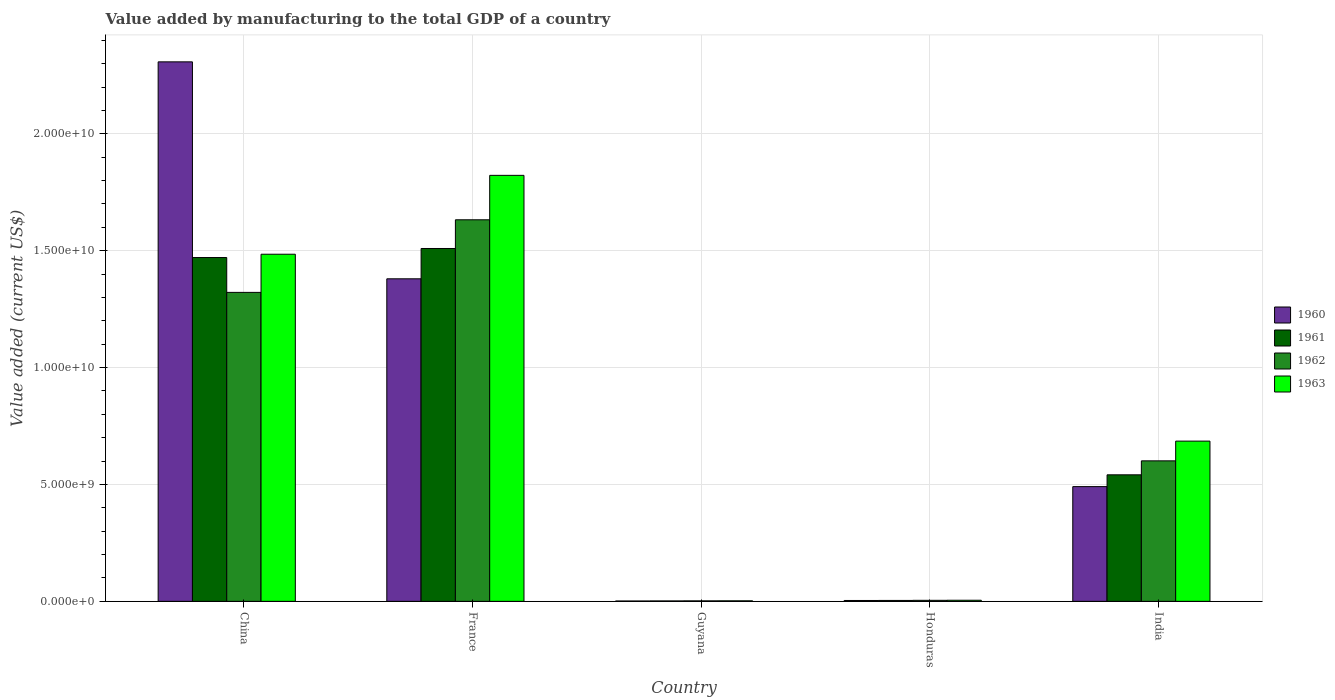Are the number of bars per tick equal to the number of legend labels?
Ensure brevity in your answer.  Yes. Are the number of bars on each tick of the X-axis equal?
Ensure brevity in your answer.  Yes. How many bars are there on the 1st tick from the left?
Offer a very short reply. 4. What is the label of the 3rd group of bars from the left?
Your answer should be very brief. Guyana. What is the value added by manufacturing to the total GDP in 1961 in Guyana?
Provide a succinct answer. 1.84e+07. Across all countries, what is the maximum value added by manufacturing to the total GDP in 1962?
Your response must be concise. 1.63e+1. Across all countries, what is the minimum value added by manufacturing to the total GDP in 1961?
Ensure brevity in your answer.  1.84e+07. In which country was the value added by manufacturing to the total GDP in 1960 minimum?
Make the answer very short. Guyana. What is the total value added by manufacturing to the total GDP in 1962 in the graph?
Ensure brevity in your answer.  3.56e+1. What is the difference between the value added by manufacturing to the total GDP in 1960 in China and that in France?
Your response must be concise. 9.28e+09. What is the difference between the value added by manufacturing to the total GDP in 1961 in Honduras and the value added by manufacturing to the total GDP in 1962 in France?
Keep it short and to the point. -1.63e+1. What is the average value added by manufacturing to the total GDP in 1960 per country?
Make the answer very short. 8.37e+09. What is the difference between the value added by manufacturing to the total GDP of/in 1963 and value added by manufacturing to the total GDP of/in 1960 in Guyana?
Provide a succinct answer. 7.29e+06. What is the ratio of the value added by manufacturing to the total GDP in 1963 in Honduras to that in India?
Provide a short and direct response. 0.01. What is the difference between the highest and the second highest value added by manufacturing to the total GDP in 1963?
Offer a very short reply. 8.00e+09. What is the difference between the highest and the lowest value added by manufacturing to the total GDP in 1960?
Offer a terse response. 2.31e+1. Is it the case that in every country, the sum of the value added by manufacturing to the total GDP in 1961 and value added by manufacturing to the total GDP in 1960 is greater than the sum of value added by manufacturing to the total GDP in 1962 and value added by manufacturing to the total GDP in 1963?
Ensure brevity in your answer.  No. What does the 2nd bar from the right in France represents?
Provide a short and direct response. 1962. Is it the case that in every country, the sum of the value added by manufacturing to the total GDP in 1961 and value added by manufacturing to the total GDP in 1960 is greater than the value added by manufacturing to the total GDP in 1962?
Your response must be concise. Yes. How many bars are there?
Ensure brevity in your answer.  20. Are all the bars in the graph horizontal?
Give a very brief answer. No. What is the difference between two consecutive major ticks on the Y-axis?
Offer a terse response. 5.00e+09. Are the values on the major ticks of Y-axis written in scientific E-notation?
Your answer should be compact. Yes. Does the graph contain grids?
Provide a short and direct response. Yes. Where does the legend appear in the graph?
Keep it short and to the point. Center right. How many legend labels are there?
Offer a very short reply. 4. What is the title of the graph?
Ensure brevity in your answer.  Value added by manufacturing to the total GDP of a country. What is the label or title of the Y-axis?
Your answer should be very brief. Value added (current US$). What is the Value added (current US$) of 1960 in China?
Ensure brevity in your answer.  2.31e+1. What is the Value added (current US$) in 1961 in China?
Your answer should be very brief. 1.47e+1. What is the Value added (current US$) in 1962 in China?
Make the answer very short. 1.32e+1. What is the Value added (current US$) in 1963 in China?
Give a very brief answer. 1.49e+1. What is the Value added (current US$) in 1960 in France?
Give a very brief answer. 1.38e+1. What is the Value added (current US$) of 1961 in France?
Make the answer very short. 1.51e+1. What is the Value added (current US$) in 1962 in France?
Your answer should be very brief. 1.63e+1. What is the Value added (current US$) of 1963 in France?
Your answer should be very brief. 1.82e+1. What is the Value added (current US$) in 1960 in Guyana?
Offer a terse response. 1.59e+07. What is the Value added (current US$) of 1961 in Guyana?
Your answer should be very brief. 1.84e+07. What is the Value added (current US$) in 1962 in Guyana?
Offer a very short reply. 2.08e+07. What is the Value added (current US$) in 1963 in Guyana?
Offer a terse response. 2.32e+07. What is the Value added (current US$) of 1960 in Honduras?
Offer a very short reply. 3.80e+07. What is the Value added (current US$) of 1961 in Honduras?
Make the answer very short. 4.00e+07. What is the Value added (current US$) of 1962 in Honduras?
Provide a succinct answer. 4.41e+07. What is the Value added (current US$) of 1963 in Honduras?
Your answer should be very brief. 4.76e+07. What is the Value added (current US$) of 1960 in India?
Make the answer very short. 4.91e+09. What is the Value added (current US$) of 1961 in India?
Make the answer very short. 5.41e+09. What is the Value added (current US$) in 1962 in India?
Provide a succinct answer. 6.01e+09. What is the Value added (current US$) of 1963 in India?
Make the answer very short. 6.85e+09. Across all countries, what is the maximum Value added (current US$) of 1960?
Your answer should be compact. 2.31e+1. Across all countries, what is the maximum Value added (current US$) in 1961?
Your response must be concise. 1.51e+1. Across all countries, what is the maximum Value added (current US$) of 1962?
Offer a terse response. 1.63e+1. Across all countries, what is the maximum Value added (current US$) in 1963?
Provide a short and direct response. 1.82e+1. Across all countries, what is the minimum Value added (current US$) of 1960?
Give a very brief answer. 1.59e+07. Across all countries, what is the minimum Value added (current US$) of 1961?
Ensure brevity in your answer.  1.84e+07. Across all countries, what is the minimum Value added (current US$) in 1962?
Offer a very short reply. 2.08e+07. Across all countries, what is the minimum Value added (current US$) in 1963?
Your response must be concise. 2.32e+07. What is the total Value added (current US$) of 1960 in the graph?
Give a very brief answer. 4.18e+1. What is the total Value added (current US$) of 1961 in the graph?
Your answer should be compact. 3.53e+1. What is the total Value added (current US$) in 1962 in the graph?
Keep it short and to the point. 3.56e+1. What is the total Value added (current US$) of 1963 in the graph?
Provide a succinct answer. 4.00e+1. What is the difference between the Value added (current US$) in 1960 in China and that in France?
Provide a short and direct response. 9.28e+09. What is the difference between the Value added (current US$) in 1961 in China and that in France?
Ensure brevity in your answer.  -3.87e+08. What is the difference between the Value added (current US$) in 1962 in China and that in France?
Offer a very short reply. -3.11e+09. What is the difference between the Value added (current US$) of 1963 in China and that in France?
Provide a short and direct response. -3.37e+09. What is the difference between the Value added (current US$) of 1960 in China and that in Guyana?
Give a very brief answer. 2.31e+1. What is the difference between the Value added (current US$) in 1961 in China and that in Guyana?
Provide a succinct answer. 1.47e+1. What is the difference between the Value added (current US$) in 1962 in China and that in Guyana?
Give a very brief answer. 1.32e+1. What is the difference between the Value added (current US$) of 1963 in China and that in Guyana?
Give a very brief answer. 1.48e+1. What is the difference between the Value added (current US$) of 1960 in China and that in Honduras?
Your answer should be very brief. 2.30e+1. What is the difference between the Value added (current US$) of 1961 in China and that in Honduras?
Provide a succinct answer. 1.47e+1. What is the difference between the Value added (current US$) in 1962 in China and that in Honduras?
Provide a succinct answer. 1.32e+1. What is the difference between the Value added (current US$) in 1963 in China and that in Honduras?
Offer a terse response. 1.48e+1. What is the difference between the Value added (current US$) of 1960 in China and that in India?
Your answer should be very brief. 1.82e+1. What is the difference between the Value added (current US$) of 1961 in China and that in India?
Offer a very short reply. 9.30e+09. What is the difference between the Value added (current US$) in 1962 in China and that in India?
Offer a very short reply. 7.21e+09. What is the difference between the Value added (current US$) of 1963 in China and that in India?
Provide a succinct answer. 8.00e+09. What is the difference between the Value added (current US$) in 1960 in France and that in Guyana?
Ensure brevity in your answer.  1.38e+1. What is the difference between the Value added (current US$) of 1961 in France and that in Guyana?
Provide a short and direct response. 1.51e+1. What is the difference between the Value added (current US$) in 1962 in France and that in Guyana?
Provide a short and direct response. 1.63e+1. What is the difference between the Value added (current US$) in 1963 in France and that in Guyana?
Keep it short and to the point. 1.82e+1. What is the difference between the Value added (current US$) of 1960 in France and that in Honduras?
Provide a succinct answer. 1.38e+1. What is the difference between the Value added (current US$) in 1961 in France and that in Honduras?
Offer a terse response. 1.51e+1. What is the difference between the Value added (current US$) of 1962 in France and that in Honduras?
Provide a short and direct response. 1.63e+1. What is the difference between the Value added (current US$) in 1963 in France and that in Honduras?
Keep it short and to the point. 1.82e+1. What is the difference between the Value added (current US$) of 1960 in France and that in India?
Offer a very short reply. 8.89e+09. What is the difference between the Value added (current US$) of 1961 in France and that in India?
Give a very brief answer. 9.68e+09. What is the difference between the Value added (current US$) of 1962 in France and that in India?
Provide a succinct answer. 1.03e+1. What is the difference between the Value added (current US$) in 1963 in France and that in India?
Keep it short and to the point. 1.14e+1. What is the difference between the Value added (current US$) of 1960 in Guyana and that in Honduras?
Your response must be concise. -2.22e+07. What is the difference between the Value added (current US$) in 1961 in Guyana and that in Honduras?
Offer a terse response. -2.17e+07. What is the difference between the Value added (current US$) in 1962 in Guyana and that in Honduras?
Your response must be concise. -2.33e+07. What is the difference between the Value added (current US$) of 1963 in Guyana and that in Honduras?
Keep it short and to the point. -2.44e+07. What is the difference between the Value added (current US$) of 1960 in Guyana and that in India?
Provide a succinct answer. -4.89e+09. What is the difference between the Value added (current US$) in 1961 in Guyana and that in India?
Ensure brevity in your answer.  -5.40e+09. What is the difference between the Value added (current US$) in 1962 in Guyana and that in India?
Offer a very short reply. -5.99e+09. What is the difference between the Value added (current US$) in 1963 in Guyana and that in India?
Your answer should be compact. -6.83e+09. What is the difference between the Value added (current US$) of 1960 in Honduras and that in India?
Offer a very short reply. -4.87e+09. What is the difference between the Value added (current US$) in 1961 in Honduras and that in India?
Give a very brief answer. -5.37e+09. What is the difference between the Value added (current US$) in 1962 in Honduras and that in India?
Your response must be concise. -5.97e+09. What is the difference between the Value added (current US$) in 1963 in Honduras and that in India?
Make the answer very short. -6.81e+09. What is the difference between the Value added (current US$) in 1960 in China and the Value added (current US$) in 1961 in France?
Keep it short and to the point. 7.98e+09. What is the difference between the Value added (current US$) in 1960 in China and the Value added (current US$) in 1962 in France?
Offer a terse response. 6.76e+09. What is the difference between the Value added (current US$) in 1960 in China and the Value added (current US$) in 1963 in France?
Offer a terse response. 4.86e+09. What is the difference between the Value added (current US$) of 1961 in China and the Value added (current US$) of 1962 in France?
Keep it short and to the point. -1.61e+09. What is the difference between the Value added (current US$) in 1961 in China and the Value added (current US$) in 1963 in France?
Your response must be concise. -3.52e+09. What is the difference between the Value added (current US$) in 1962 in China and the Value added (current US$) in 1963 in France?
Your answer should be compact. -5.01e+09. What is the difference between the Value added (current US$) in 1960 in China and the Value added (current US$) in 1961 in Guyana?
Give a very brief answer. 2.31e+1. What is the difference between the Value added (current US$) of 1960 in China and the Value added (current US$) of 1962 in Guyana?
Your response must be concise. 2.31e+1. What is the difference between the Value added (current US$) of 1960 in China and the Value added (current US$) of 1963 in Guyana?
Your answer should be compact. 2.31e+1. What is the difference between the Value added (current US$) in 1961 in China and the Value added (current US$) in 1962 in Guyana?
Make the answer very short. 1.47e+1. What is the difference between the Value added (current US$) in 1961 in China and the Value added (current US$) in 1963 in Guyana?
Offer a very short reply. 1.47e+1. What is the difference between the Value added (current US$) in 1962 in China and the Value added (current US$) in 1963 in Guyana?
Ensure brevity in your answer.  1.32e+1. What is the difference between the Value added (current US$) of 1960 in China and the Value added (current US$) of 1961 in Honduras?
Give a very brief answer. 2.30e+1. What is the difference between the Value added (current US$) of 1960 in China and the Value added (current US$) of 1962 in Honduras?
Your response must be concise. 2.30e+1. What is the difference between the Value added (current US$) in 1960 in China and the Value added (current US$) in 1963 in Honduras?
Provide a succinct answer. 2.30e+1. What is the difference between the Value added (current US$) of 1961 in China and the Value added (current US$) of 1962 in Honduras?
Your answer should be very brief. 1.47e+1. What is the difference between the Value added (current US$) of 1961 in China and the Value added (current US$) of 1963 in Honduras?
Make the answer very short. 1.47e+1. What is the difference between the Value added (current US$) of 1962 in China and the Value added (current US$) of 1963 in Honduras?
Provide a short and direct response. 1.32e+1. What is the difference between the Value added (current US$) of 1960 in China and the Value added (current US$) of 1961 in India?
Your answer should be compact. 1.77e+1. What is the difference between the Value added (current US$) in 1960 in China and the Value added (current US$) in 1962 in India?
Provide a short and direct response. 1.71e+1. What is the difference between the Value added (current US$) of 1960 in China and the Value added (current US$) of 1963 in India?
Your response must be concise. 1.62e+1. What is the difference between the Value added (current US$) of 1961 in China and the Value added (current US$) of 1962 in India?
Your answer should be compact. 8.70e+09. What is the difference between the Value added (current US$) in 1961 in China and the Value added (current US$) in 1963 in India?
Keep it short and to the point. 7.85e+09. What is the difference between the Value added (current US$) of 1962 in China and the Value added (current US$) of 1963 in India?
Your answer should be very brief. 6.36e+09. What is the difference between the Value added (current US$) of 1960 in France and the Value added (current US$) of 1961 in Guyana?
Provide a succinct answer. 1.38e+1. What is the difference between the Value added (current US$) in 1960 in France and the Value added (current US$) in 1962 in Guyana?
Your answer should be very brief. 1.38e+1. What is the difference between the Value added (current US$) of 1960 in France and the Value added (current US$) of 1963 in Guyana?
Keep it short and to the point. 1.38e+1. What is the difference between the Value added (current US$) in 1961 in France and the Value added (current US$) in 1962 in Guyana?
Ensure brevity in your answer.  1.51e+1. What is the difference between the Value added (current US$) in 1961 in France and the Value added (current US$) in 1963 in Guyana?
Your answer should be compact. 1.51e+1. What is the difference between the Value added (current US$) in 1962 in France and the Value added (current US$) in 1963 in Guyana?
Your answer should be very brief. 1.63e+1. What is the difference between the Value added (current US$) in 1960 in France and the Value added (current US$) in 1961 in Honduras?
Your answer should be compact. 1.38e+1. What is the difference between the Value added (current US$) of 1960 in France and the Value added (current US$) of 1962 in Honduras?
Provide a succinct answer. 1.38e+1. What is the difference between the Value added (current US$) in 1960 in France and the Value added (current US$) in 1963 in Honduras?
Your answer should be compact. 1.38e+1. What is the difference between the Value added (current US$) in 1961 in France and the Value added (current US$) in 1962 in Honduras?
Your response must be concise. 1.51e+1. What is the difference between the Value added (current US$) of 1961 in France and the Value added (current US$) of 1963 in Honduras?
Make the answer very short. 1.50e+1. What is the difference between the Value added (current US$) in 1962 in France and the Value added (current US$) in 1963 in Honduras?
Offer a very short reply. 1.63e+1. What is the difference between the Value added (current US$) of 1960 in France and the Value added (current US$) of 1961 in India?
Make the answer very short. 8.39e+09. What is the difference between the Value added (current US$) in 1960 in France and the Value added (current US$) in 1962 in India?
Keep it short and to the point. 7.79e+09. What is the difference between the Value added (current US$) in 1960 in France and the Value added (current US$) in 1963 in India?
Offer a very short reply. 6.94e+09. What is the difference between the Value added (current US$) of 1961 in France and the Value added (current US$) of 1962 in India?
Ensure brevity in your answer.  9.09e+09. What is the difference between the Value added (current US$) in 1961 in France and the Value added (current US$) in 1963 in India?
Provide a short and direct response. 8.24e+09. What is the difference between the Value added (current US$) in 1962 in France and the Value added (current US$) in 1963 in India?
Provide a short and direct response. 9.47e+09. What is the difference between the Value added (current US$) in 1960 in Guyana and the Value added (current US$) in 1961 in Honduras?
Make the answer very short. -2.42e+07. What is the difference between the Value added (current US$) in 1960 in Guyana and the Value added (current US$) in 1962 in Honduras?
Provide a succinct answer. -2.82e+07. What is the difference between the Value added (current US$) of 1960 in Guyana and the Value added (current US$) of 1963 in Honduras?
Ensure brevity in your answer.  -3.17e+07. What is the difference between the Value added (current US$) of 1961 in Guyana and the Value added (current US$) of 1962 in Honduras?
Ensure brevity in your answer.  -2.57e+07. What is the difference between the Value added (current US$) in 1961 in Guyana and the Value added (current US$) in 1963 in Honduras?
Keep it short and to the point. -2.92e+07. What is the difference between the Value added (current US$) of 1962 in Guyana and the Value added (current US$) of 1963 in Honduras?
Your answer should be compact. -2.68e+07. What is the difference between the Value added (current US$) in 1960 in Guyana and the Value added (current US$) in 1961 in India?
Provide a short and direct response. -5.40e+09. What is the difference between the Value added (current US$) in 1960 in Guyana and the Value added (current US$) in 1962 in India?
Offer a very short reply. -5.99e+09. What is the difference between the Value added (current US$) of 1960 in Guyana and the Value added (current US$) of 1963 in India?
Offer a terse response. -6.84e+09. What is the difference between the Value added (current US$) in 1961 in Guyana and the Value added (current US$) in 1962 in India?
Provide a succinct answer. -5.99e+09. What is the difference between the Value added (current US$) of 1961 in Guyana and the Value added (current US$) of 1963 in India?
Keep it short and to the point. -6.84e+09. What is the difference between the Value added (current US$) in 1962 in Guyana and the Value added (current US$) in 1963 in India?
Provide a succinct answer. -6.83e+09. What is the difference between the Value added (current US$) of 1960 in Honduras and the Value added (current US$) of 1961 in India?
Offer a terse response. -5.38e+09. What is the difference between the Value added (current US$) of 1960 in Honduras and the Value added (current US$) of 1962 in India?
Ensure brevity in your answer.  -5.97e+09. What is the difference between the Value added (current US$) of 1960 in Honduras and the Value added (current US$) of 1963 in India?
Keep it short and to the point. -6.82e+09. What is the difference between the Value added (current US$) of 1961 in Honduras and the Value added (current US$) of 1962 in India?
Offer a terse response. -5.97e+09. What is the difference between the Value added (current US$) of 1961 in Honduras and the Value added (current US$) of 1963 in India?
Give a very brief answer. -6.81e+09. What is the difference between the Value added (current US$) in 1962 in Honduras and the Value added (current US$) in 1963 in India?
Your answer should be compact. -6.81e+09. What is the average Value added (current US$) of 1960 per country?
Keep it short and to the point. 8.37e+09. What is the average Value added (current US$) of 1961 per country?
Your answer should be very brief. 7.06e+09. What is the average Value added (current US$) of 1962 per country?
Make the answer very short. 7.12e+09. What is the average Value added (current US$) in 1963 per country?
Keep it short and to the point. 8.00e+09. What is the difference between the Value added (current US$) in 1960 and Value added (current US$) in 1961 in China?
Offer a terse response. 8.37e+09. What is the difference between the Value added (current US$) of 1960 and Value added (current US$) of 1962 in China?
Your answer should be very brief. 9.86e+09. What is the difference between the Value added (current US$) of 1960 and Value added (current US$) of 1963 in China?
Ensure brevity in your answer.  8.23e+09. What is the difference between the Value added (current US$) of 1961 and Value added (current US$) of 1962 in China?
Your response must be concise. 1.49e+09. What is the difference between the Value added (current US$) in 1961 and Value added (current US$) in 1963 in China?
Make the answer very short. -1.42e+08. What is the difference between the Value added (current US$) in 1962 and Value added (current US$) in 1963 in China?
Make the answer very short. -1.63e+09. What is the difference between the Value added (current US$) of 1960 and Value added (current US$) of 1961 in France?
Ensure brevity in your answer.  -1.30e+09. What is the difference between the Value added (current US$) of 1960 and Value added (current US$) of 1962 in France?
Your answer should be compact. -2.52e+09. What is the difference between the Value added (current US$) in 1960 and Value added (current US$) in 1963 in France?
Offer a terse response. -4.43e+09. What is the difference between the Value added (current US$) in 1961 and Value added (current US$) in 1962 in France?
Your response must be concise. -1.23e+09. What is the difference between the Value added (current US$) of 1961 and Value added (current US$) of 1963 in France?
Make the answer very short. -3.13e+09. What is the difference between the Value added (current US$) of 1962 and Value added (current US$) of 1963 in France?
Give a very brief answer. -1.90e+09. What is the difference between the Value added (current US$) in 1960 and Value added (current US$) in 1961 in Guyana?
Your response must be concise. -2.51e+06. What is the difference between the Value added (current US$) of 1960 and Value added (current US$) of 1962 in Guyana?
Give a very brief answer. -4.90e+06. What is the difference between the Value added (current US$) of 1960 and Value added (current US$) of 1963 in Guyana?
Offer a very short reply. -7.29e+06. What is the difference between the Value added (current US$) in 1961 and Value added (current US$) in 1962 in Guyana?
Ensure brevity in your answer.  -2.39e+06. What is the difference between the Value added (current US$) in 1961 and Value added (current US$) in 1963 in Guyana?
Your answer should be very brief. -4.78e+06. What is the difference between the Value added (current US$) in 1962 and Value added (current US$) in 1963 in Guyana?
Offer a very short reply. -2.39e+06. What is the difference between the Value added (current US$) in 1960 and Value added (current US$) in 1961 in Honduras?
Your response must be concise. -2.00e+06. What is the difference between the Value added (current US$) in 1960 and Value added (current US$) in 1962 in Honduras?
Provide a short and direct response. -6.05e+06. What is the difference between the Value added (current US$) of 1960 and Value added (current US$) of 1963 in Honduras?
Offer a very short reply. -9.50e+06. What is the difference between the Value added (current US$) in 1961 and Value added (current US$) in 1962 in Honduras?
Ensure brevity in your answer.  -4.05e+06. What is the difference between the Value added (current US$) in 1961 and Value added (current US$) in 1963 in Honduras?
Keep it short and to the point. -7.50e+06. What is the difference between the Value added (current US$) in 1962 and Value added (current US$) in 1963 in Honduras?
Offer a terse response. -3.45e+06. What is the difference between the Value added (current US$) in 1960 and Value added (current US$) in 1961 in India?
Offer a terse response. -5.05e+08. What is the difference between the Value added (current US$) of 1960 and Value added (current US$) of 1962 in India?
Offer a terse response. -1.10e+09. What is the difference between the Value added (current US$) of 1960 and Value added (current US$) of 1963 in India?
Your response must be concise. -1.95e+09. What is the difference between the Value added (current US$) in 1961 and Value added (current US$) in 1962 in India?
Give a very brief answer. -5.97e+08. What is the difference between the Value added (current US$) of 1961 and Value added (current US$) of 1963 in India?
Your response must be concise. -1.44e+09. What is the difference between the Value added (current US$) of 1962 and Value added (current US$) of 1963 in India?
Provide a succinct answer. -8.44e+08. What is the ratio of the Value added (current US$) in 1960 in China to that in France?
Offer a very short reply. 1.67. What is the ratio of the Value added (current US$) in 1961 in China to that in France?
Ensure brevity in your answer.  0.97. What is the ratio of the Value added (current US$) of 1962 in China to that in France?
Your answer should be very brief. 0.81. What is the ratio of the Value added (current US$) in 1963 in China to that in France?
Provide a succinct answer. 0.81. What is the ratio of the Value added (current US$) in 1960 in China to that in Guyana?
Make the answer very short. 1454.66. What is the ratio of the Value added (current US$) of 1961 in China to that in Guyana?
Offer a terse response. 800.48. What is the ratio of the Value added (current US$) in 1962 in China to that in Guyana?
Offer a very short reply. 636.5. What is the ratio of the Value added (current US$) in 1963 in China to that in Guyana?
Your answer should be compact. 641.28. What is the ratio of the Value added (current US$) of 1960 in China to that in Honduras?
Make the answer very short. 606.59. What is the ratio of the Value added (current US$) of 1961 in China to that in Honduras?
Keep it short and to the point. 367.26. What is the ratio of the Value added (current US$) in 1962 in China to that in Honduras?
Make the answer very short. 299.73. What is the ratio of the Value added (current US$) in 1963 in China to that in Honduras?
Give a very brief answer. 312.32. What is the ratio of the Value added (current US$) of 1960 in China to that in India?
Ensure brevity in your answer.  4.7. What is the ratio of the Value added (current US$) in 1961 in China to that in India?
Provide a succinct answer. 2.72. What is the ratio of the Value added (current US$) of 1962 in China to that in India?
Make the answer very short. 2.2. What is the ratio of the Value added (current US$) in 1963 in China to that in India?
Offer a terse response. 2.17. What is the ratio of the Value added (current US$) of 1960 in France to that in Guyana?
Give a very brief answer. 869.7. What is the ratio of the Value added (current US$) of 1961 in France to that in Guyana?
Offer a very short reply. 821.55. What is the ratio of the Value added (current US$) in 1962 in France to that in Guyana?
Make the answer very short. 786.05. What is the ratio of the Value added (current US$) in 1963 in France to that in Guyana?
Give a very brief answer. 786.97. What is the ratio of the Value added (current US$) in 1960 in France to that in Honduras?
Your answer should be very brief. 362.66. What is the ratio of the Value added (current US$) in 1961 in France to that in Honduras?
Your answer should be compact. 376.93. What is the ratio of the Value added (current US$) of 1962 in France to that in Honduras?
Ensure brevity in your answer.  370.15. What is the ratio of the Value added (current US$) in 1963 in France to that in Honduras?
Give a very brief answer. 383.28. What is the ratio of the Value added (current US$) in 1960 in France to that in India?
Your response must be concise. 2.81. What is the ratio of the Value added (current US$) in 1961 in France to that in India?
Your answer should be compact. 2.79. What is the ratio of the Value added (current US$) of 1962 in France to that in India?
Provide a short and direct response. 2.72. What is the ratio of the Value added (current US$) in 1963 in France to that in India?
Provide a short and direct response. 2.66. What is the ratio of the Value added (current US$) of 1960 in Guyana to that in Honduras?
Provide a succinct answer. 0.42. What is the ratio of the Value added (current US$) in 1961 in Guyana to that in Honduras?
Make the answer very short. 0.46. What is the ratio of the Value added (current US$) in 1962 in Guyana to that in Honduras?
Keep it short and to the point. 0.47. What is the ratio of the Value added (current US$) in 1963 in Guyana to that in Honduras?
Your answer should be compact. 0.49. What is the ratio of the Value added (current US$) in 1960 in Guyana to that in India?
Your response must be concise. 0. What is the ratio of the Value added (current US$) of 1961 in Guyana to that in India?
Your answer should be very brief. 0. What is the ratio of the Value added (current US$) in 1962 in Guyana to that in India?
Give a very brief answer. 0. What is the ratio of the Value added (current US$) of 1963 in Guyana to that in India?
Ensure brevity in your answer.  0. What is the ratio of the Value added (current US$) in 1960 in Honduras to that in India?
Ensure brevity in your answer.  0.01. What is the ratio of the Value added (current US$) in 1961 in Honduras to that in India?
Provide a succinct answer. 0.01. What is the ratio of the Value added (current US$) of 1962 in Honduras to that in India?
Provide a short and direct response. 0.01. What is the ratio of the Value added (current US$) of 1963 in Honduras to that in India?
Your answer should be compact. 0.01. What is the difference between the highest and the second highest Value added (current US$) of 1960?
Give a very brief answer. 9.28e+09. What is the difference between the highest and the second highest Value added (current US$) of 1961?
Make the answer very short. 3.87e+08. What is the difference between the highest and the second highest Value added (current US$) in 1962?
Provide a succinct answer. 3.11e+09. What is the difference between the highest and the second highest Value added (current US$) in 1963?
Offer a terse response. 3.37e+09. What is the difference between the highest and the lowest Value added (current US$) in 1960?
Keep it short and to the point. 2.31e+1. What is the difference between the highest and the lowest Value added (current US$) of 1961?
Provide a short and direct response. 1.51e+1. What is the difference between the highest and the lowest Value added (current US$) of 1962?
Your answer should be very brief. 1.63e+1. What is the difference between the highest and the lowest Value added (current US$) in 1963?
Your response must be concise. 1.82e+1. 